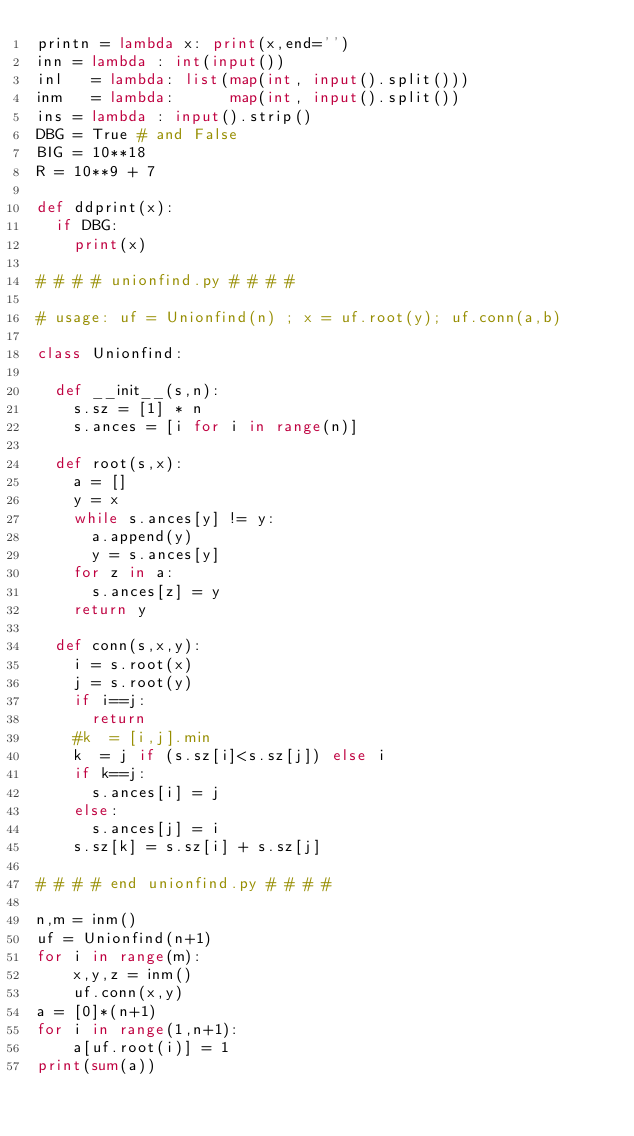Convert code to text. <code><loc_0><loc_0><loc_500><loc_500><_Python_>printn = lambda x: print(x,end='')
inn = lambda : int(input())
inl   = lambda: list(map(int, input().split()))
inm   = lambda:      map(int, input().split())
ins = lambda : input().strip()
DBG = True # and False
BIG = 10**18
R = 10**9 + 7

def ddprint(x):
  if DBG:
    print(x)

# # # # unionfind.py # # # #

# usage: uf = Unionfind(n) ; x = uf.root(y); uf.conn(a,b)

class Unionfind:

  def __init__(s,n):
    s.sz = [1] * n
    s.ances = [i for i in range(n)]

  def root(s,x):
    a = []
    y = x
    while s.ances[y] != y:
      a.append(y)
      y = s.ances[y]
    for z in a:
      s.ances[z] = y
    return y

  def conn(s,x,y):
    i = s.root(x)
    j = s.root(y)
    if i==j:
      return
    #k  = [i,j].min
    k  = j if (s.sz[i]<s.sz[j]) else i
    if k==j:
      s.ances[i] = j
    else:
      s.ances[j] = i
    s.sz[k] = s.sz[i] + s.sz[j]

# # # # end unionfind.py # # # #

n,m = inm()
uf = Unionfind(n+1)
for i in range(m):
    x,y,z = inm()
    uf.conn(x,y)
a = [0]*(n+1)
for i in range(1,n+1):
    a[uf.root(i)] = 1
print(sum(a))
</code> 